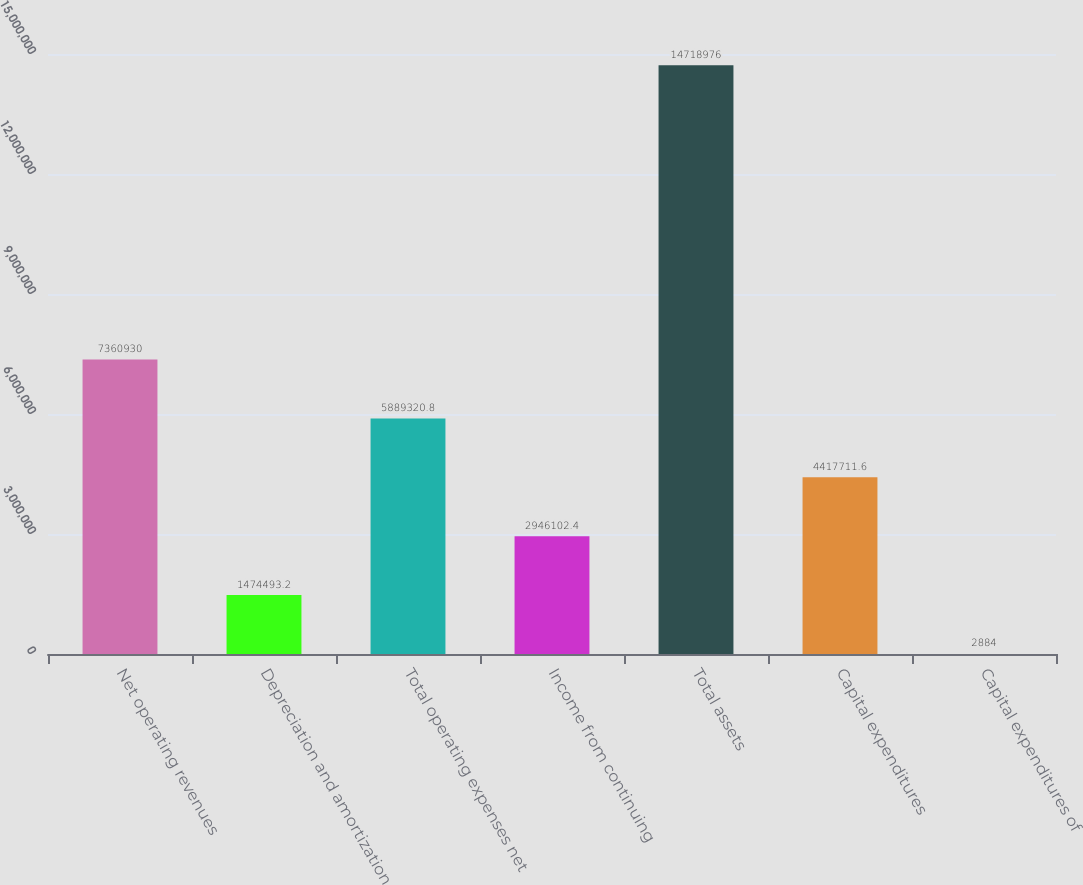Convert chart to OTSL. <chart><loc_0><loc_0><loc_500><loc_500><bar_chart><fcel>Net operating revenues<fcel>Depreciation and amortization<fcel>Total operating expenses net<fcel>Income from continuing<fcel>Total assets<fcel>Capital expenditures<fcel>Capital expenditures of<nl><fcel>7.36093e+06<fcel>1.47449e+06<fcel>5.88932e+06<fcel>2.9461e+06<fcel>1.4719e+07<fcel>4.41771e+06<fcel>2884<nl></chart> 